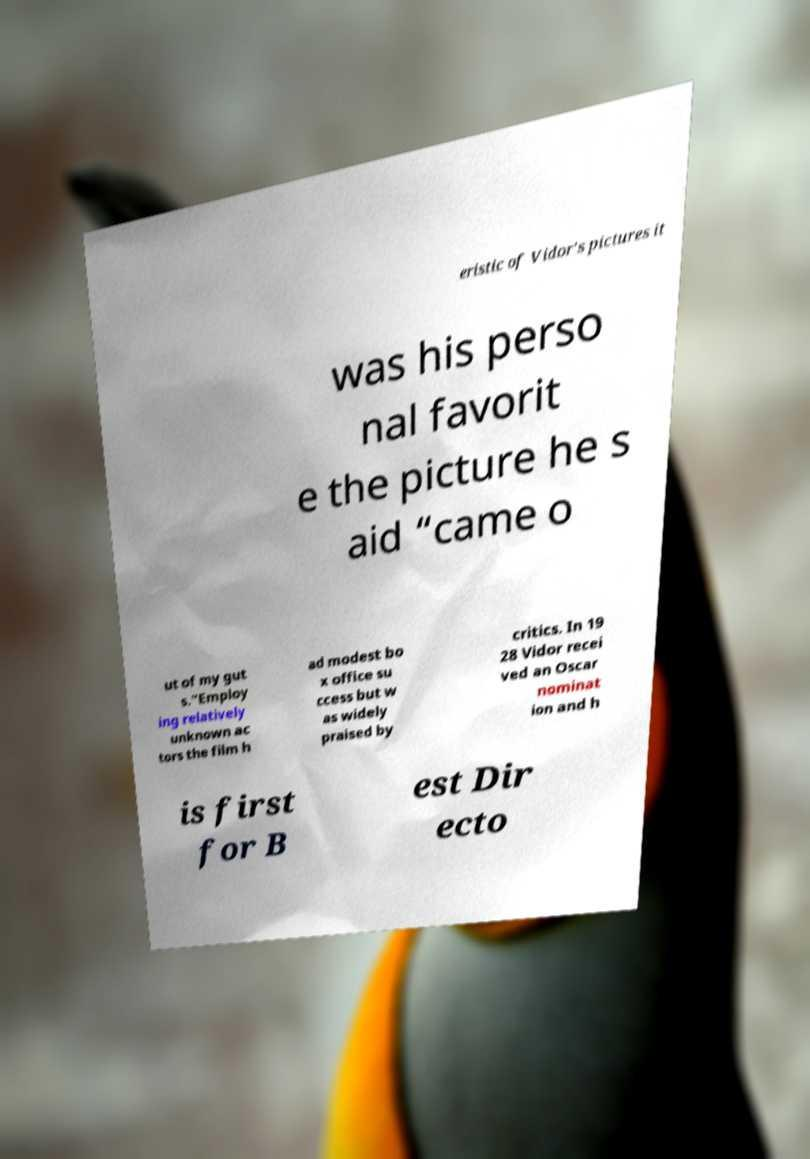Could you extract and type out the text from this image? eristic of Vidor's pictures it was his perso nal favorit e the picture he s aid “came o ut of my gut s.”Employ ing relatively unknown ac tors the film h ad modest bo x office su ccess but w as widely praised by critics. In 19 28 Vidor recei ved an Oscar nominat ion and h is first for B est Dir ecto 